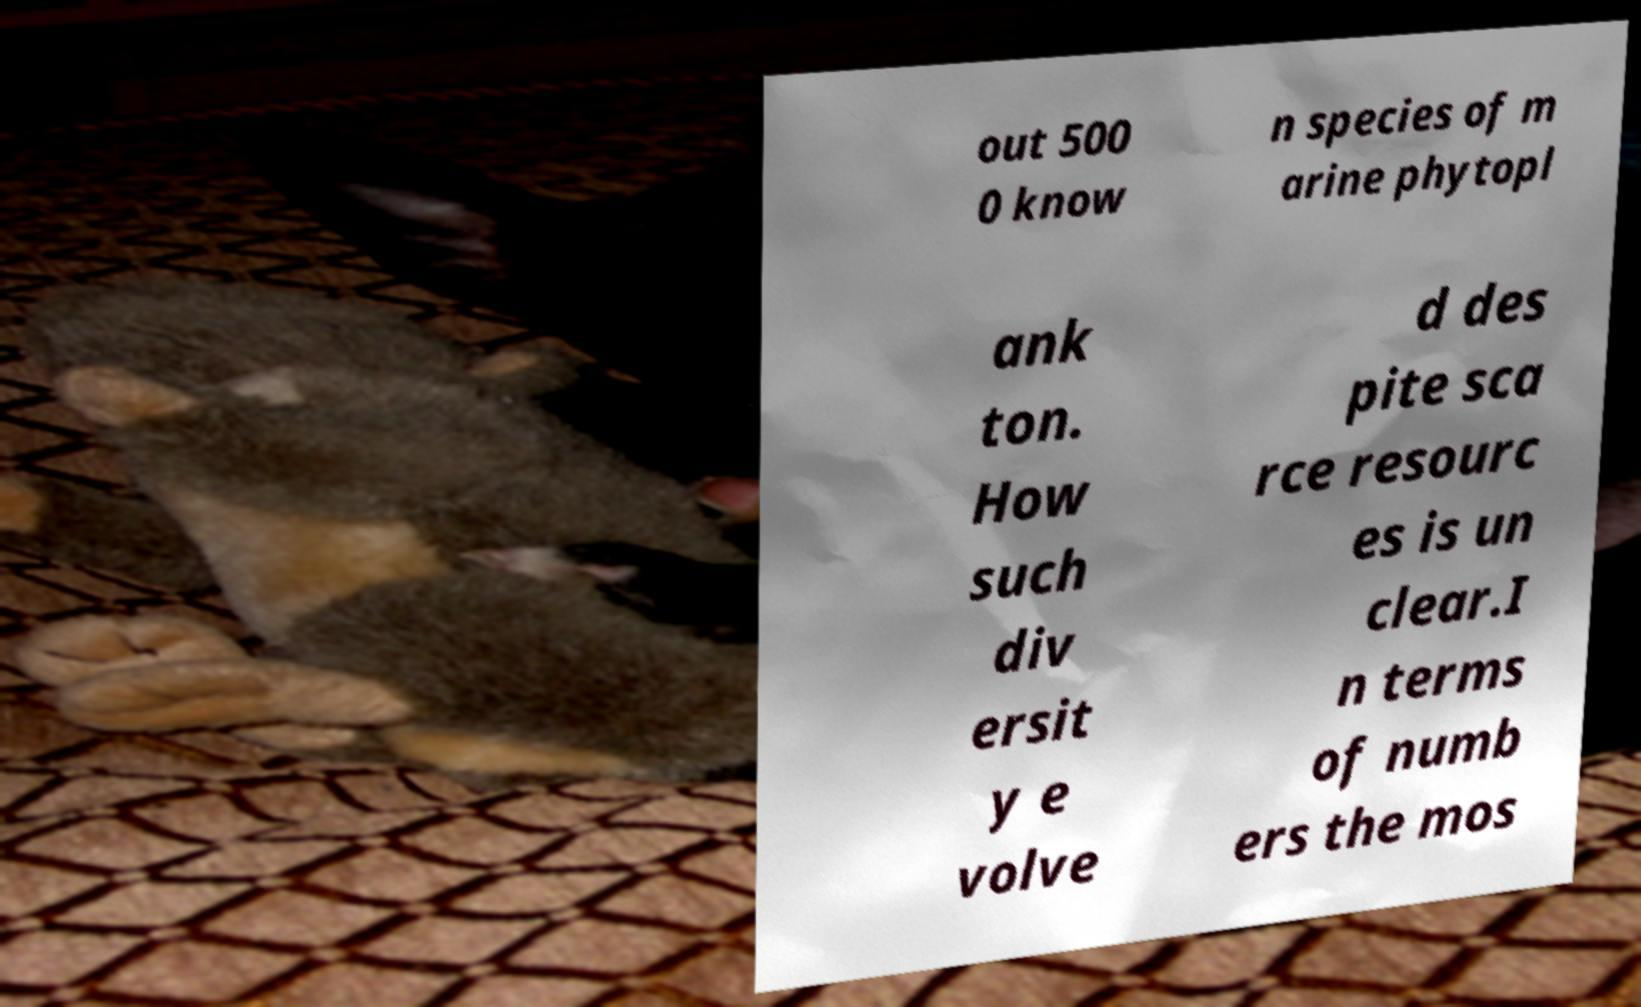Please read and relay the text visible in this image. What does it say? out 500 0 know n species of m arine phytopl ank ton. How such div ersit y e volve d des pite sca rce resourc es is un clear.I n terms of numb ers the mos 